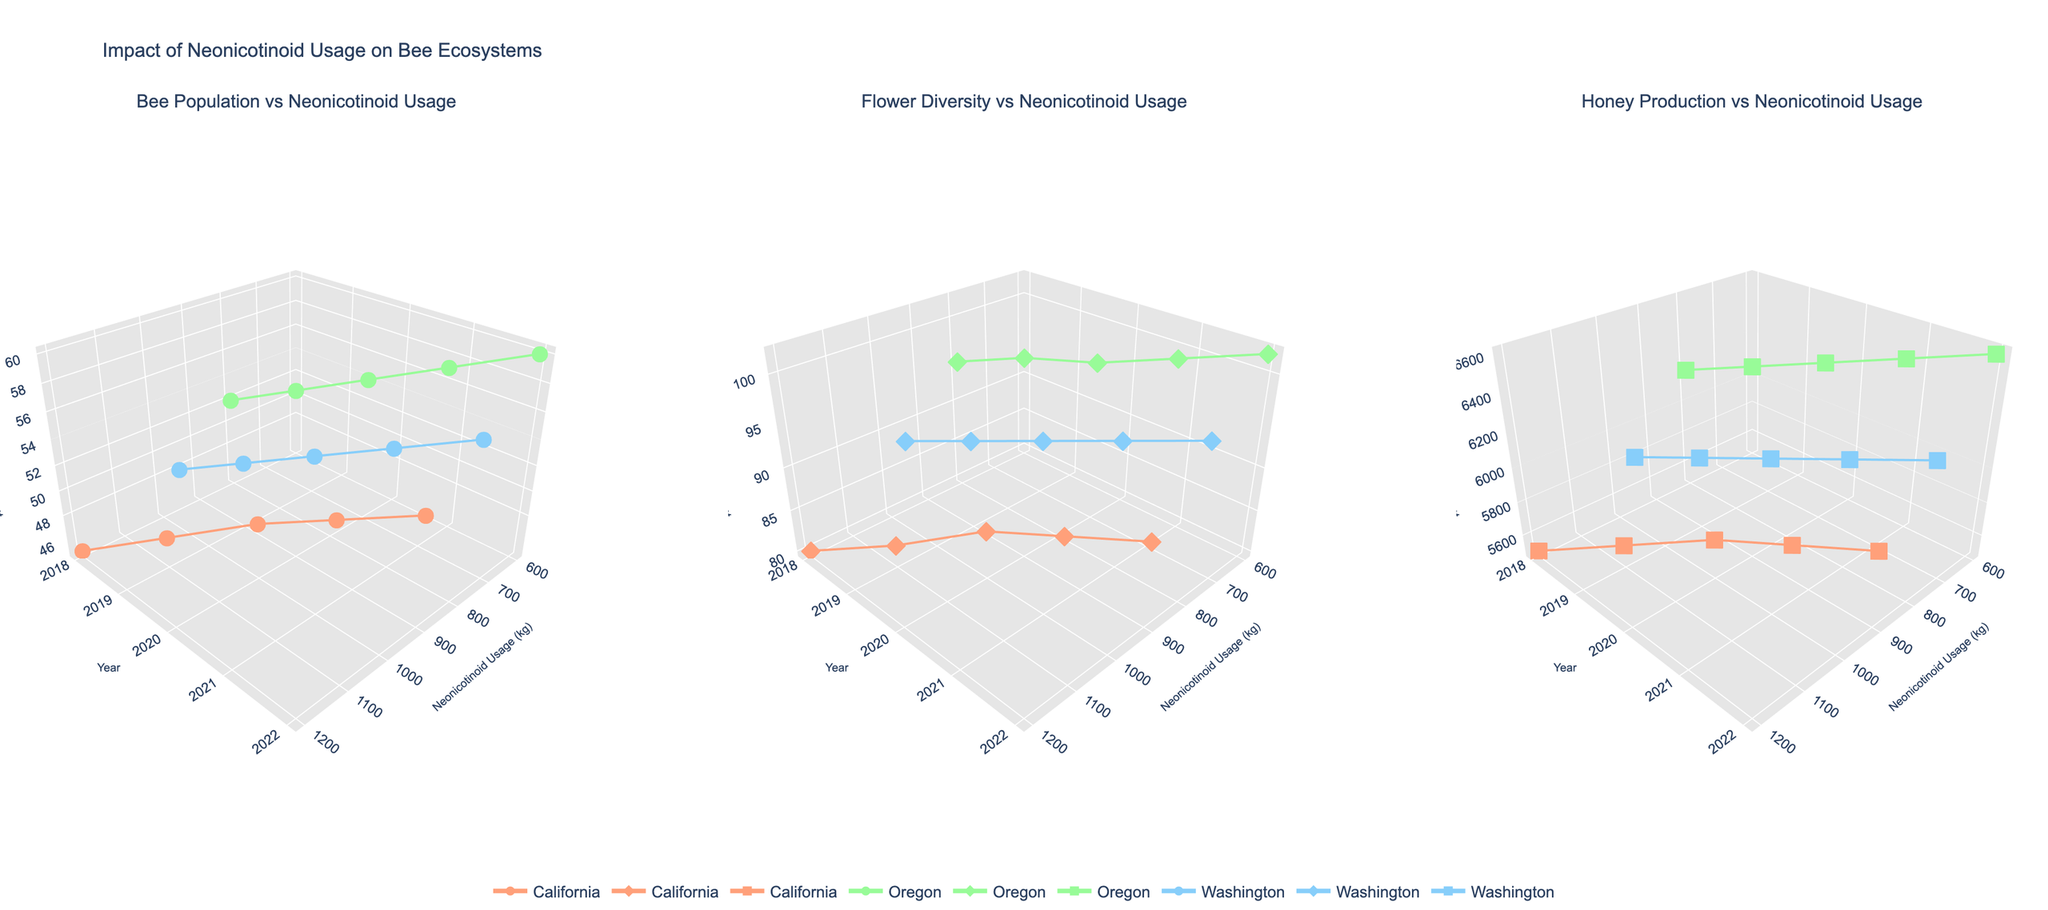What is the title of the figure? The title of the figure is displayed at the top of the plot. It is "Impact of Neonicotinoid Usage on Bee Ecosystems."
Answer: Impact of Neonicotinoid Usage on Bee Ecosystems How many subplots are in the figure? The figure is divided into three equal sections, each representing a different subplot.
Answer: 3 In which subplot can you find information about honey production? The subplot titles indicate that the third subplot from the left, titled "Honey Production vs Neonicotinoid Usage," contains information about honey production.
Answer: The third subplot What color is used to represent data points for Oregon across all subplots? Each region has a unique color, and Oregon is represented consistently in all three subplots by the greenish color. This can be confirmed by looking at the markers for Oregon in the legend and the plots.
Answer: Greenish Which year does California have the highest bee population density? In the subplot "Bee Population vs Neonicotinoid Usage," follow California’s data points and compare the z-values. The highest z-value for bee population density for California is in 2022.
Answer: 2022 What's the average flower species count in Washington from 2018 to 2022? In the subplot "Flower Diversity vs Neonicotinoid Usage," identify Washington’s z-values for each year from 2018 to 2022. These values are 88, 90, 92, 94, 96. Sum these values and divide by the number of years (5). (88 + 90 + 92 + 94 + 96) / 5 = 460 / 5 = 92
Answer: 92 Which region shows a consistent decrease in neonicotinoid usage from 2018 to 2022? Look at the x-axis trend for each region across the years in any of the subplots. California’s x-values decrease consistently from 1200 in 2018 to 900 in 2022.
Answer: California Between 2018 and 2022, which region experienced the largest increase in honey production? In the subplot "Honey Production vs Neonicotinoid Usage," compare honey production z-values for each region in 2018 and 2022. Oregon’s production increased from 6200 in 2018 to 6600 in 2022, which is the largest increase.
Answer: Oregon Is there evidence suggesting neonicotinoid usage affects honey production in California? In the subplot "Honey Production vs Neonicotinoid Usage," observe California’s data points. Honey production slightly increases as neonicotinoid usage decreases from 2018 to 2022. This inverse relationship suggests an effect.
Answer: Yes 